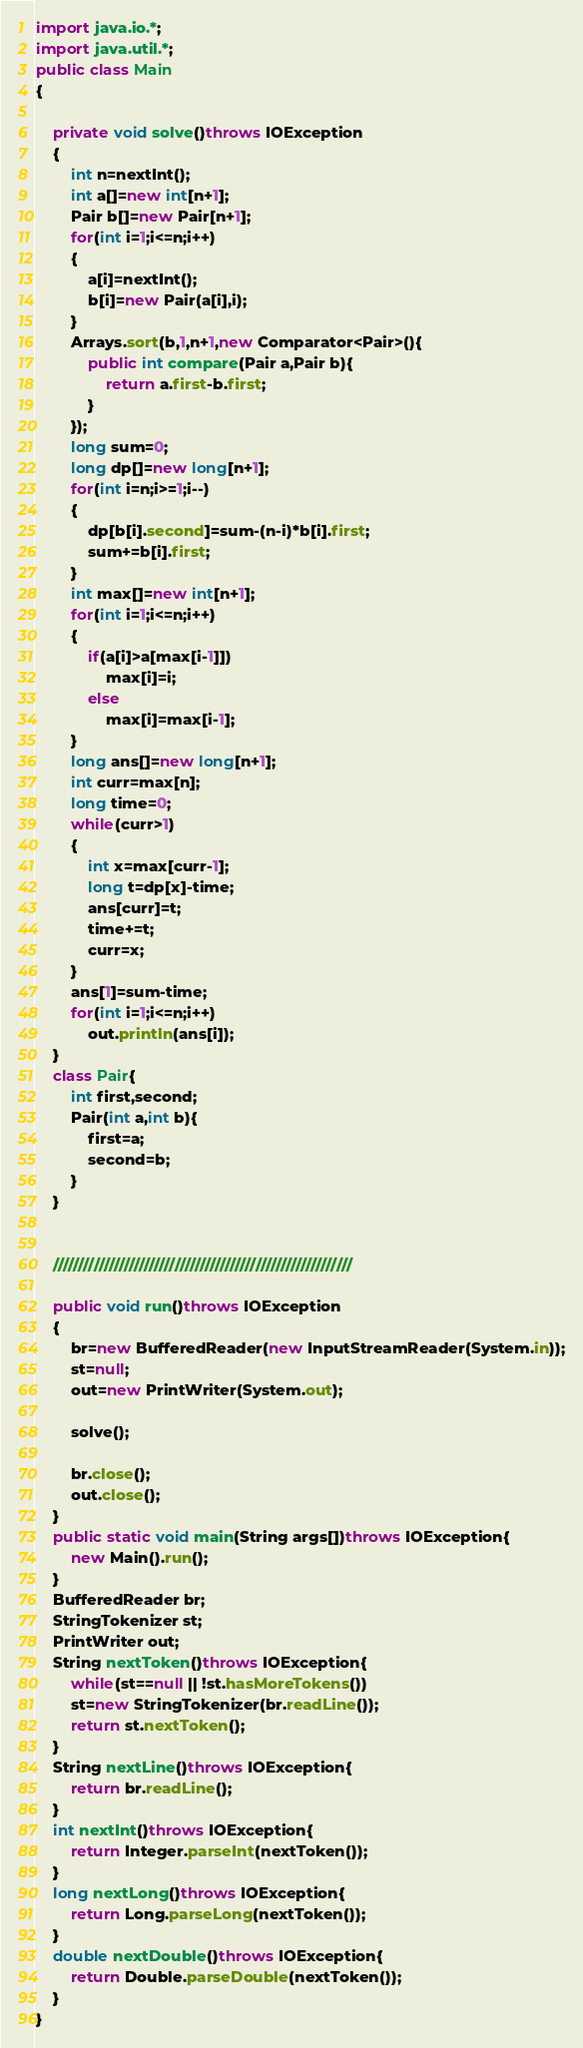Convert code to text. <code><loc_0><loc_0><loc_500><loc_500><_Java_>import java.io.*;
import java.util.*;
public class Main
{
	
	private void solve()throws IOException
	{
		int n=nextInt();
		int a[]=new int[n+1];
		Pair b[]=new Pair[n+1];
		for(int i=1;i<=n;i++)
		{
			a[i]=nextInt();
			b[i]=new Pair(a[i],i);
		}
		Arrays.sort(b,1,n+1,new Comparator<Pair>(){
			public int compare(Pair a,Pair b){
				return a.first-b.first;
			}
		});
		long sum=0;
		long dp[]=new long[n+1];
		for(int i=n;i>=1;i--)
		{
			dp[b[i].second]=sum-(n-i)*b[i].first;
			sum+=b[i].first;
		}
		int max[]=new int[n+1];
		for(int i=1;i<=n;i++)
		{
			if(a[i]>a[max[i-1]])
				max[i]=i;
			else
				max[i]=max[i-1];
		}
		long ans[]=new long[n+1];
		int curr=max[n];
		long time=0;
		while(curr>1)
		{
			int x=max[curr-1];
			long t=dp[x]-time;
			ans[curr]=t;
			time+=t;
			curr=x;
		}
		ans[1]=sum-time;
		for(int i=1;i<=n;i++)
			out.println(ans[i]);
	}
	class Pair{
	    int first,second;
	    Pair(int a,int b){
	        first=a;
	        second=b;
	    }
	}

	 
	///////////////////////////////////////////////////////////

	public void run()throws IOException
	{
		br=new BufferedReader(new InputStreamReader(System.in));
		st=null;
		out=new PrintWriter(System.out);

		solve();
		
		br.close();
		out.close();
	}
	public static void main(String args[])throws IOException{
		new Main().run();
	}
	BufferedReader br;
	StringTokenizer st;
	PrintWriter out;
	String nextToken()throws IOException{
		while(st==null || !st.hasMoreTokens())
		st=new StringTokenizer(br.readLine());
		return st.nextToken();
	}
	String nextLine()throws IOException{
		return br.readLine();
	}
	int nextInt()throws IOException{
		return Integer.parseInt(nextToken());
	}
	long nextLong()throws IOException{
		return Long.parseLong(nextToken());
	}
	double nextDouble()throws IOException{
		return Double.parseDouble(nextToken());
	}
}</code> 